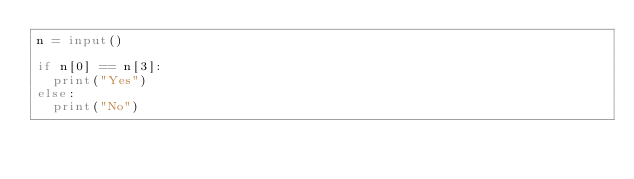Convert code to text. <code><loc_0><loc_0><loc_500><loc_500><_Python_>n = input()

if n[0] == n[3]:
  print("Yes")
else:
  print("No")
</code> 